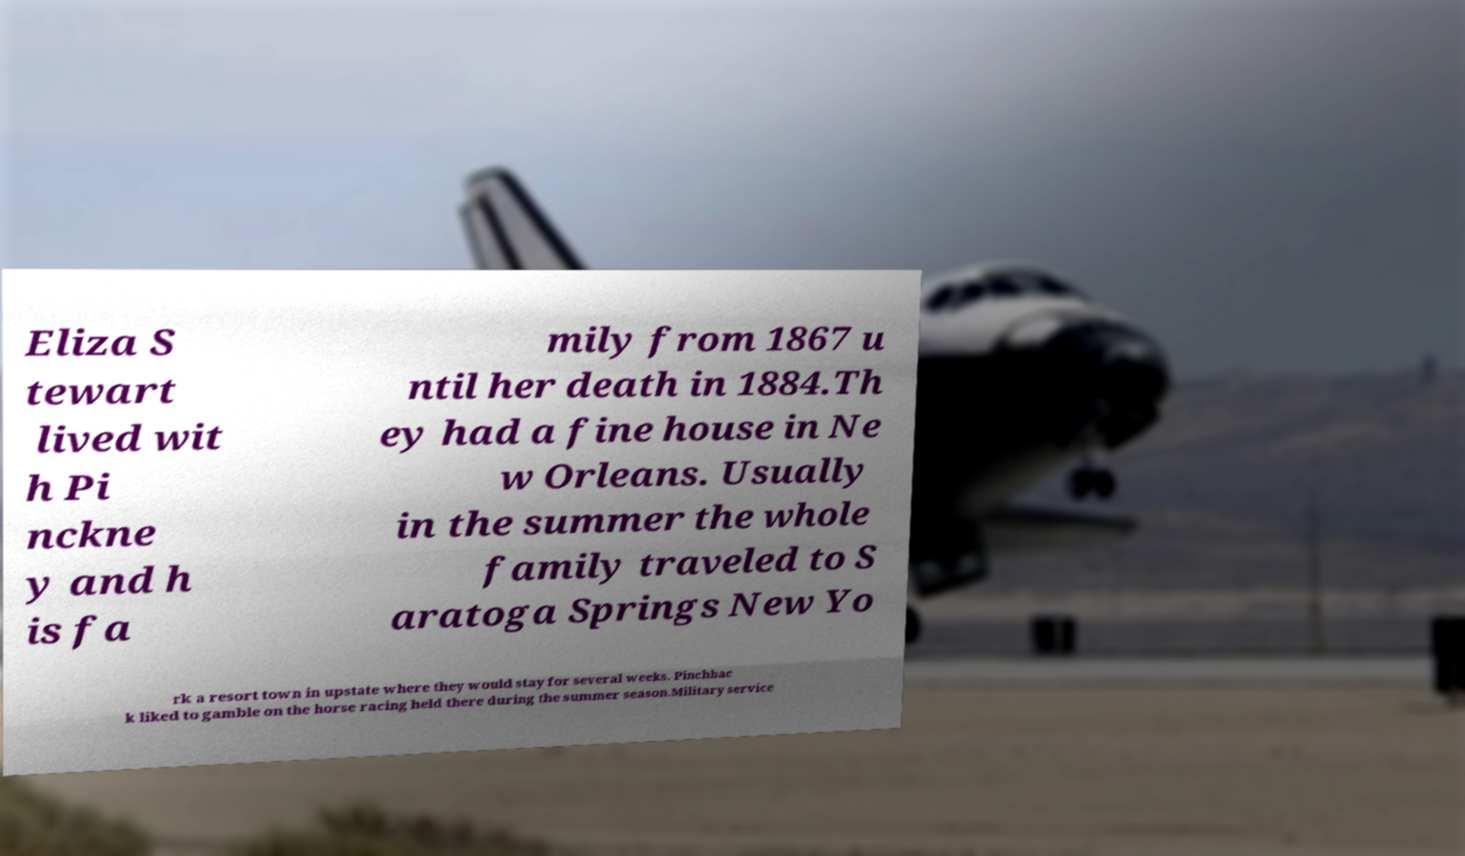Please identify and transcribe the text found in this image. Eliza S tewart lived wit h Pi nckne y and h is fa mily from 1867 u ntil her death in 1884.Th ey had a fine house in Ne w Orleans. Usually in the summer the whole family traveled to S aratoga Springs New Yo rk a resort town in upstate where they would stay for several weeks. Pinchbac k liked to gamble on the horse racing held there during the summer season.Military service 